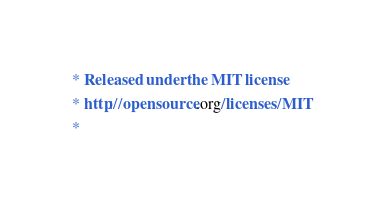<code> <loc_0><loc_0><loc_500><loc_500><_CSS_> * Released under the MIT license
 * http://opensource.org/licenses/MIT
 *</code> 